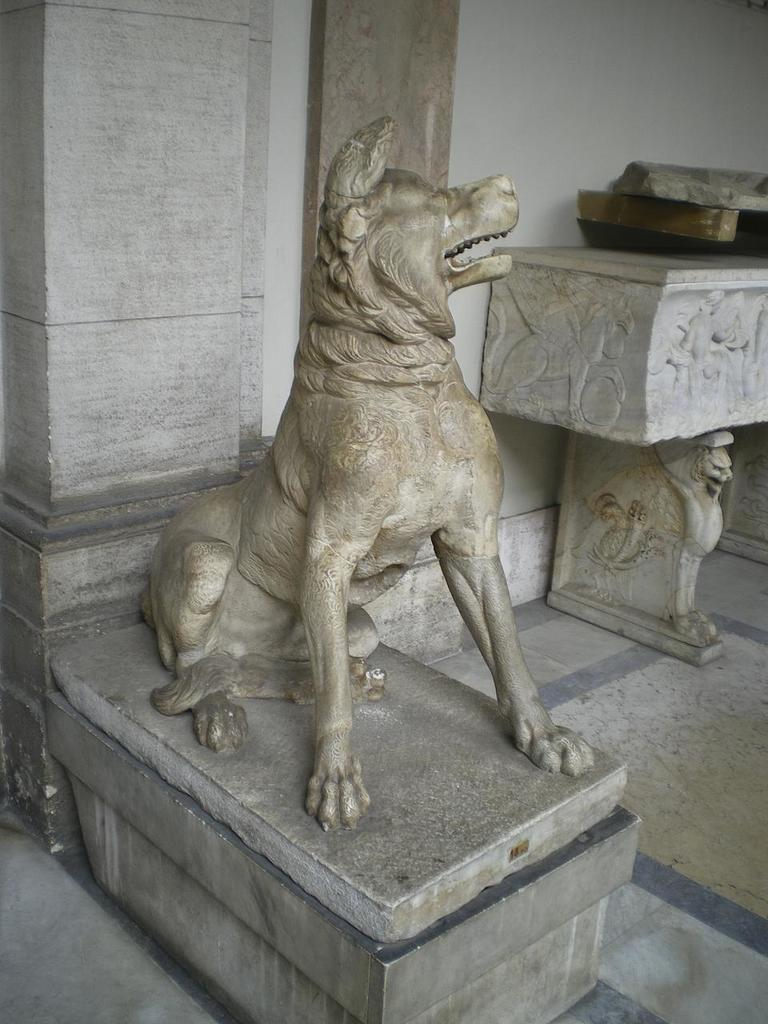What is the main subject of the image? The main subject of the image is a sculpture of a dog. What can be observed about the sculpture's surface? The sculpture has carved surfaces. How many sisters does the dog in the sculpture have? The image does not provide information about the dog's family or any sisters, as it is a sculpture and not a living dog. 